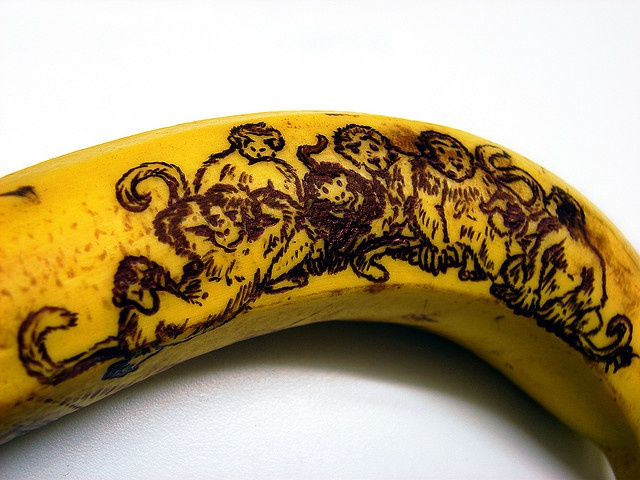Describe the objects in this image and their specific colors. I can see a banana in white, black, orange, maroon, and olive tones in this image. 